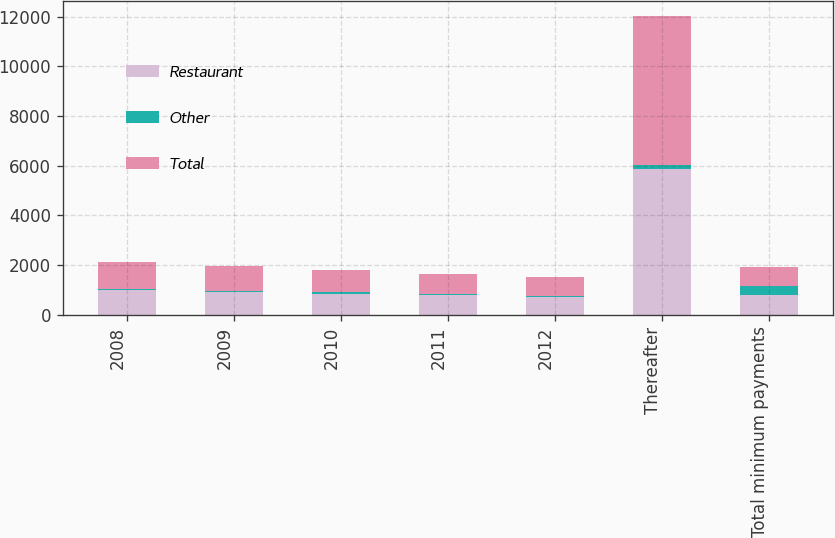Convert chart to OTSL. <chart><loc_0><loc_0><loc_500><loc_500><stacked_bar_chart><ecel><fcel>2008<fcel>2009<fcel>2010<fcel>2011<fcel>2012<fcel>Thereafter<fcel>Total minimum payments<nl><fcel>Restaurant<fcel>989.7<fcel>918.2<fcel>853.9<fcel>786.8<fcel>729.6<fcel>5869.5<fcel>786.8<nl><fcel>Other<fcel>64.1<fcel>55.4<fcel>44.6<fcel>35.2<fcel>27.7<fcel>139.1<fcel>366.1<nl><fcel>Total<fcel>1053.8<fcel>973.6<fcel>898.5<fcel>822<fcel>757.3<fcel>6008.6<fcel>786.8<nl></chart> 